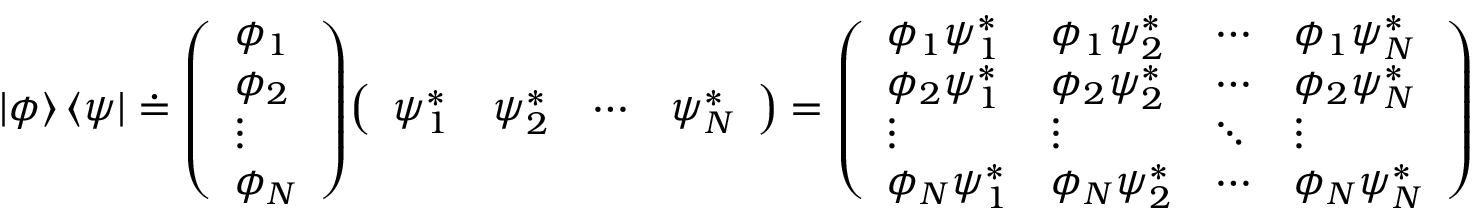Convert formula to latex. <formula><loc_0><loc_0><loc_500><loc_500>| \phi \rangle \, \langle \psi | \doteq { \left ( \begin{array} { l } { \phi _ { 1 } } \\ { \phi _ { 2 } } \\ { \vdots } \\ { \phi _ { N } } \end{array} \right ) } { \left ( \begin{array} { l l l l } { \psi _ { 1 } ^ { * } } & { \psi _ { 2 } ^ { * } } & { \cdots } & { \psi _ { N } ^ { * } } \end{array} \right ) } = { \left ( \begin{array} { l l l l } { \phi _ { 1 } \psi _ { 1 } ^ { * } } & { \phi _ { 1 } \psi _ { 2 } ^ { * } } & { \cdots } & { \phi _ { 1 } \psi _ { N } ^ { * } } \\ { \phi _ { 2 } \psi _ { 1 } ^ { * } } & { \phi _ { 2 } \psi _ { 2 } ^ { * } } & { \cdots } & { \phi _ { 2 } \psi _ { N } ^ { * } } \\ { \vdots } & { \vdots } & { \ddots } & { \vdots } \\ { \phi _ { N } \psi _ { 1 } ^ { * } } & { \phi _ { N } \psi _ { 2 } ^ { * } } & { \cdots } & { \phi _ { N } \psi _ { N } ^ { * } } \end{array} \right ) }</formula> 